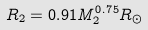Convert formula to latex. <formula><loc_0><loc_0><loc_500><loc_500>R _ { 2 } = 0 . 9 1 M _ { 2 } ^ { 0 . 7 5 } R _ { \odot }</formula> 